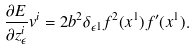Convert formula to latex. <formula><loc_0><loc_0><loc_500><loc_500>\frac { \partial E } { \partial z ^ { i } _ { \epsilon } } v ^ { i } = 2 b ^ { 2 } \delta _ { \epsilon 1 } f ^ { 2 } ( x ^ { 1 } ) f ^ { \prime } ( x ^ { 1 } ) .</formula> 